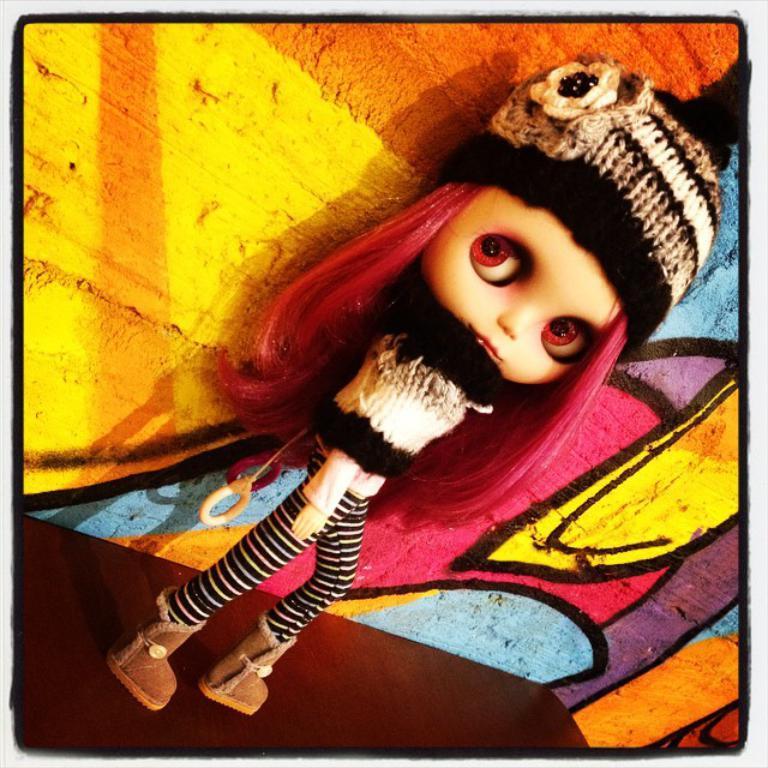Please provide a concise description of this image. This is an edited image. We can see a doll on the surface. Behind the doll, there is a colorful wall. 